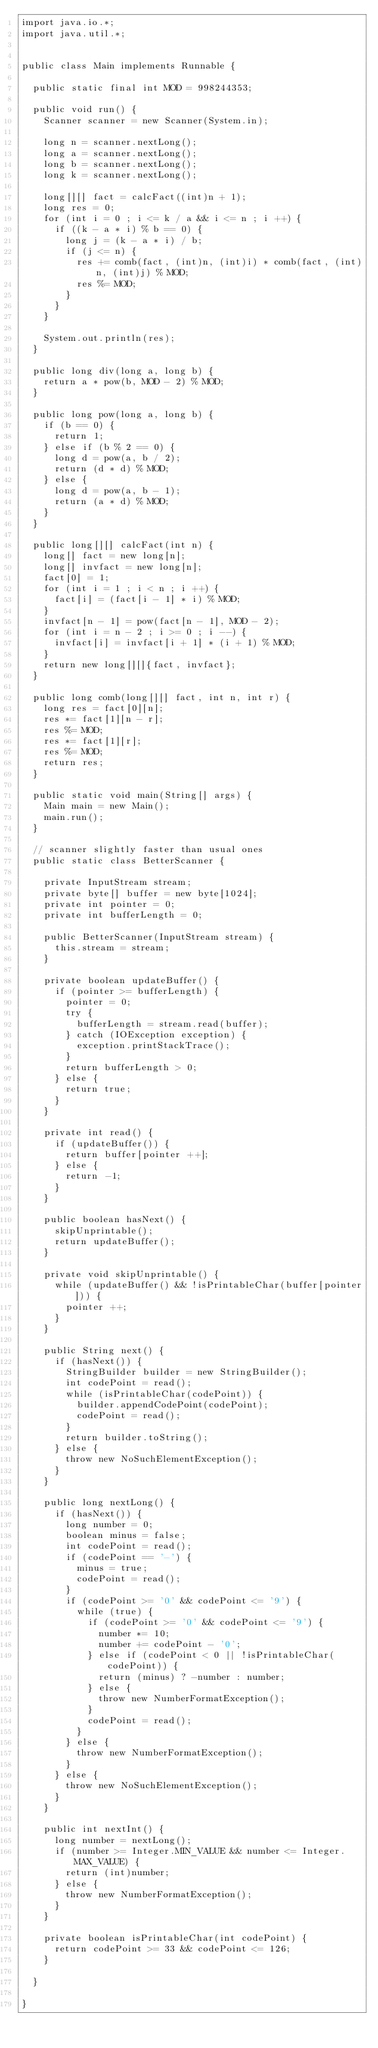<code> <loc_0><loc_0><loc_500><loc_500><_Java_>import java.io.*;
import java.util.*;
 
 
public class Main implements Runnable {
 
  public static final int MOD = 998244353;

  public void run() {
    Scanner scanner = new Scanner(System.in);

    long n = scanner.nextLong();
    long a = scanner.nextLong(); 
    long b = scanner.nextLong(); 
    long k = scanner.nextLong();

    long[][] fact = calcFact((int)n + 1);
    long res = 0;
    for (int i = 0 ; i <= k / a && i <= n ; i ++) {
      if ((k - a * i) % b == 0) {
        long j = (k - a * i) / b;
        if (j <= n) {
          res += comb(fact, (int)n, (int)i) * comb(fact, (int)n, (int)j) % MOD;
          res %= MOD;
        }
      }
    }

    System.out.println(res);
  }

  public long div(long a, long b) {
    return a * pow(b, MOD - 2) % MOD;
  }

  public long pow(long a, long b) {
    if (b == 0) {
      return 1;
    } else if (b % 2 == 0) {
      long d = pow(a, b / 2);
      return (d * d) % MOD;
    } else {
      long d = pow(a, b - 1);
      return (a * d) % MOD;
    }
  }

  public long[][] calcFact(int n) {
    long[] fact = new long[n];
    long[] invfact = new long[n];
    fact[0] = 1;
    for (int i = 1 ; i < n ; i ++) {
      fact[i] = (fact[i - 1] * i) % MOD;
    }
    invfact[n - 1] = pow(fact[n - 1], MOD - 2);
    for (int i = n - 2 ; i >= 0 ; i --) {
      invfact[i] = invfact[i + 1] * (i + 1) % MOD;
    }
    return new long[][]{fact, invfact};
  }

  public long comb(long[][] fact, int n, int r) {
    long res = fact[0][n];
    res *= fact[1][n - r];
    res %= MOD;
    res *= fact[1][r];
    res %= MOD;
    return res;
  }

  public static void main(String[] args) {
    Main main = new Main();
    main.run();
  }
 
  // scanner slightly faster than usual ones
  public static class BetterScanner {
 
    private InputStream stream;
    private byte[] buffer = new byte[1024];
    private int pointer = 0;
    private int bufferLength = 0;
 
    public BetterScanner(InputStream stream) {
      this.stream = stream;
    }
 
    private boolean updateBuffer() {
      if (pointer >= bufferLength) {
        pointer = 0;
        try {
          bufferLength = stream.read(buffer);
        } catch (IOException exception) {
          exception.printStackTrace();
        }
        return bufferLength > 0;
      } else {
        return true;
      }
    }
 
    private int read() {
      if (updateBuffer()) {
        return buffer[pointer ++];
      } else {
        return -1;
      }
    }
 
    public boolean hasNext() {
      skipUnprintable();
      return updateBuffer();
    }
 
    private void skipUnprintable() { 
      while (updateBuffer() && !isPrintableChar(buffer[pointer])) {
        pointer ++;
      }
    }
 
    public String next() {
      if (hasNext()) {
        StringBuilder builder = new StringBuilder();
        int codePoint = read();
        while (isPrintableChar(codePoint)) {
          builder.appendCodePoint(codePoint);
          codePoint = read();
        }
        return builder.toString();
      } else {
        throw new NoSuchElementException();
      }
    }
 
    public long nextLong() {
      if (hasNext()) {
        long number = 0;
        boolean minus = false;
        int codePoint = read();
        if (codePoint == '-') {
          minus = true;
          codePoint = read();
        }
        if (codePoint >= '0' && codePoint <= '9') {
          while (true) {
            if (codePoint >= '0' && codePoint <= '9') {
              number *= 10;
              number += codePoint - '0';
            } else if (codePoint < 0 || !isPrintableChar(codePoint)) {
              return (minus) ? -number : number;
            } else {
              throw new NumberFormatException();
            }
            codePoint = read();
          }
        } else {
          throw new NumberFormatException();
        }
      } else {
        throw new NoSuchElementException();
      }
    }
 
    public int nextInt() {
      long number = nextLong();
      if (number >= Integer.MIN_VALUE && number <= Integer.MAX_VALUE) {
        return (int)number;
      } else {
        throw new NumberFormatException();
      }
    }
 
    private boolean isPrintableChar(int codePoint) {
      return codePoint >= 33 && codePoint <= 126;
    }
 
  }
 
}
</code> 